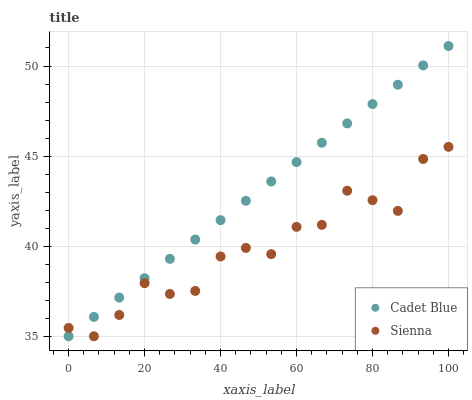Does Sienna have the minimum area under the curve?
Answer yes or no. Yes. Does Cadet Blue have the maximum area under the curve?
Answer yes or no. Yes. Does Cadet Blue have the minimum area under the curve?
Answer yes or no. No. Is Cadet Blue the smoothest?
Answer yes or no. Yes. Is Sienna the roughest?
Answer yes or no. Yes. Is Cadet Blue the roughest?
Answer yes or no. No. Does Sienna have the lowest value?
Answer yes or no. Yes. Does Cadet Blue have the highest value?
Answer yes or no. Yes. Does Cadet Blue intersect Sienna?
Answer yes or no. Yes. Is Cadet Blue less than Sienna?
Answer yes or no. No. Is Cadet Blue greater than Sienna?
Answer yes or no. No. 